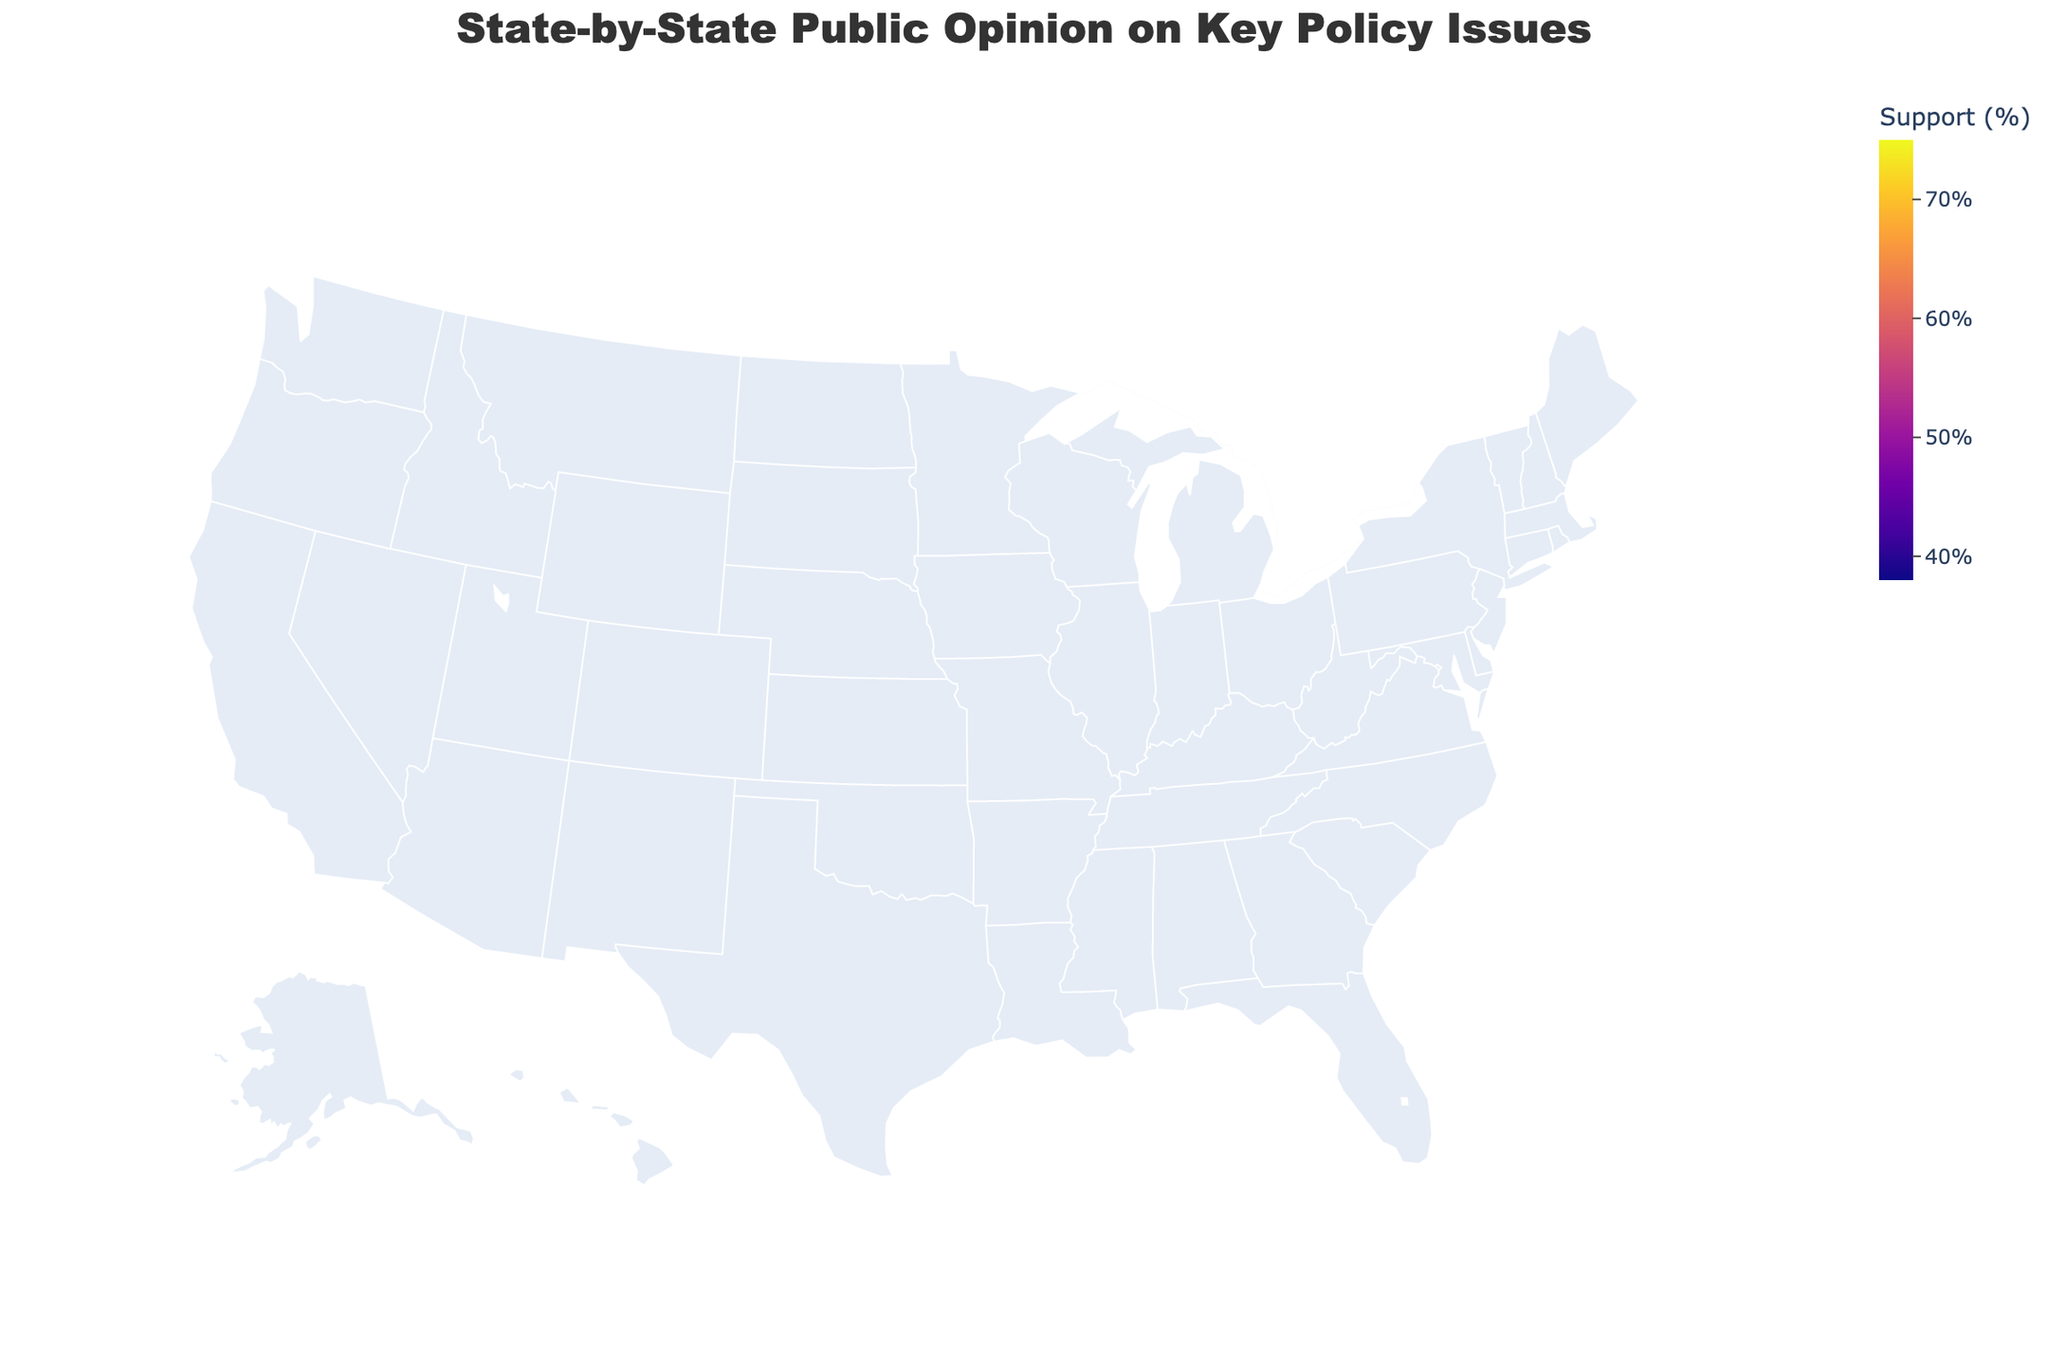What's the title of the figure? The title of the figure is centered at the top and is one of the most prominent text elements on the plot. We read the title directly from the figure.
Answer: State-by-State Public Opinion on Key Policy Issues What is the universal healthcare support percentage in New York? Find New York on the map, look at the corresponding color, and hover over it to see the exact percentage.
Answer: 70% Which state has the highest support for universal healthcare? Identify the state with the darkest color representing the highest support for universal healthcare. Massachusetts has the highest support at 75%.
Answer: Massachusetts How does the support for gun control in California compare with Texas? Hover over California and Texas, then read and compare the percentages. California shows a support of 65%, while Texas shows 38%.
Answer: California has higher support (65% vs 38% in Texas) What's the average support for climate action across New York, California, and Washington? Extract the climate action support values: New York (75%), California (78%), Washington (76%). Sum these values and divide by the number of states (3). (75 + 78 + 76) / 3 = 76.33.
Answer: 76.33% Which state has the lowest support for universal healthcare, and what is the percentage? Identify the lightest-colored state representing the lowest support. Hover to see the exact value. Alabama has the lowest at 38%.
Answer: Alabama, 38% What's the difference in support for universal healthcare between Oregon and Tennessee? Find the percentages of universal healthcare support for Oregon (70%) and Tennessee (42%). Calculate the difference (70 - 42).
Answer: 28% How many states have more than 60% support for universal healthcare? Count the number of states with universal healthcare support values greater than 60%. The states are California, New York, Illinois, Michigan, Washington, Massachusetts, Colorado, Maryland, Minnesota, and Oregon.
Answer: 10 Which state has the most balanced support across all three policy issues? Identify states where the support percentages for universal healthcare, gun control, and climate action are closest to each other. Maryland’s support percentages are 67% for universal healthcare, 65% for gun control, and 72% for climate action.
Answer: Maryland What is the color scale used to represent universal healthcare support? Look at the color bar to the side of the map, the range of colors depicts different levels of support.
Answer: Plasma 